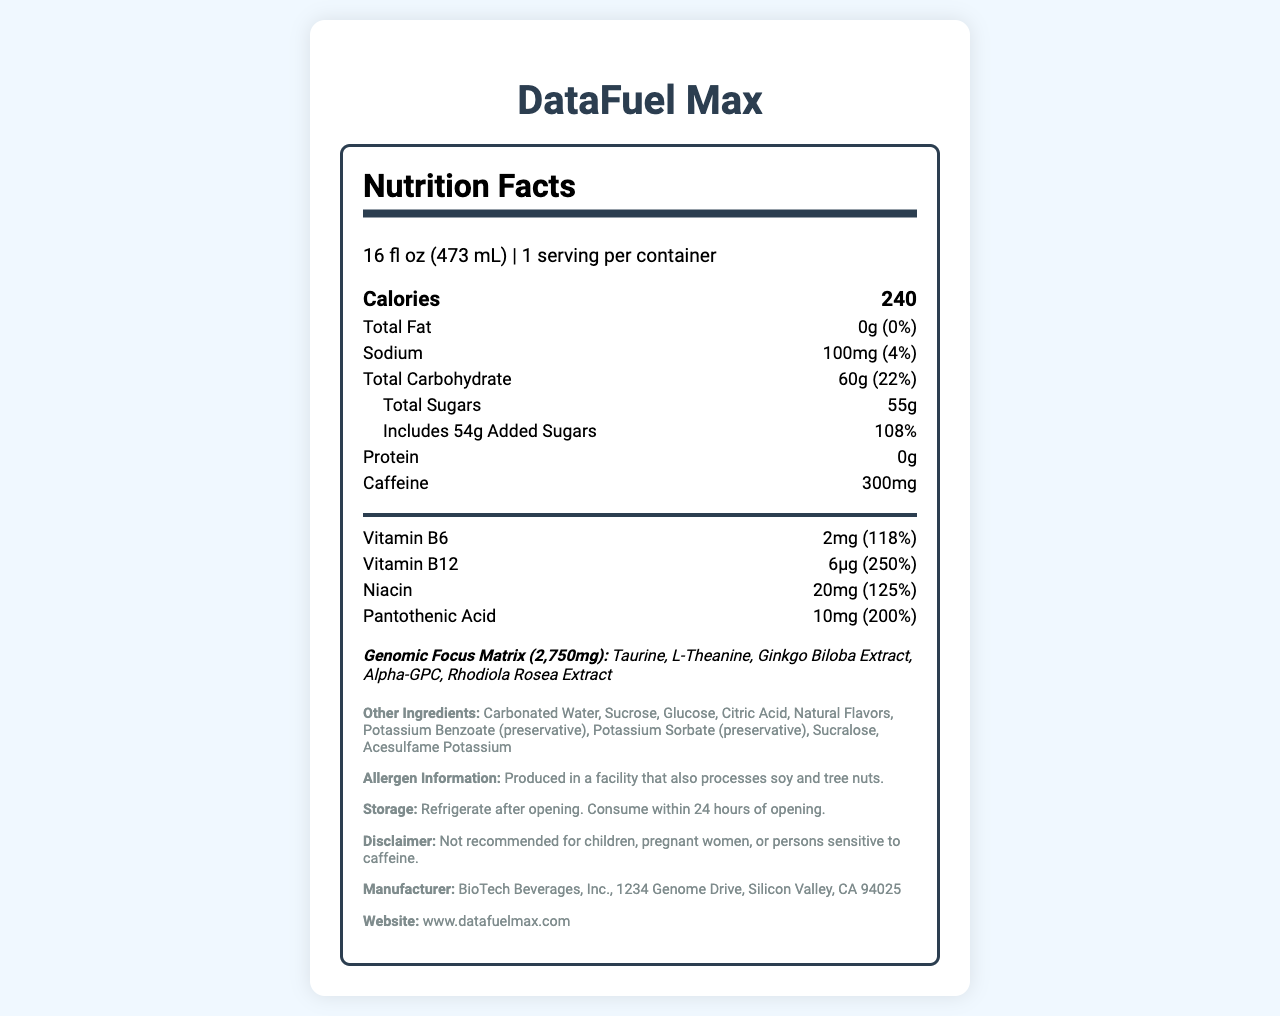What is the serving size of DataFuel Max? The serving size is clearly mentioned at the top of the nutrition facts section as "16 fl oz (473 mL)".
Answer: 16 fl oz (473 mL) What is the total amount of caffeine in one serving of this beverage? The nutrition facts section lists the amount of caffeine as 300mg.
Answer: 300mg What percentage of the daily value for Vitamin B12 does DataFuel Max provide? In the vitamins and minerals section, it is stated that Vitamin B12 provides 250% of the daily value.
Answer: 250% How many grams of added sugars are in one serving? The document lists the amount of added sugars under the total sugars section as 54g.
Answer: 54g Name one ingredient in the proprietary blend "Genomic Focus Matrix." The proprietary blend section lists the ingredients, one of which is Taurine.
Answer: Taurine Which of the following is true about the allergen information? A. Contains soy B. Contains tree nuts C. Produced in a facility that processes soy D. Produced in a facility that processes milk The allergen information states that the product is "Produced in a facility that processes soy and tree nuts."
Answer: C How much sodium is in each serving? A. 50mg B. 100mg C. 150mg D. 200mg The sodium content is listed as 100mg.
Answer: B Is this beverage recommended for children? The disclaimer clearly states "Not recommended for children, pregnant women, or persons sensitive to caffeine."
Answer: No Summarize the main idea of this Nutrition Facts Label. This beverage, called DataFuel Max, is designed for high-energy needs and contains substantial caffeine and vitamins. The label highlights its nutritional content, proprietary blend ingredients, allergen processes, and storage guidelines.
Answer: DataFuel Max is a high-energy beverage with significant amounts of caffeine, vitamins, and a proprietary blend targeted for professionals, packed with sugars and free of fats and proteins, and includes specific storage and allergen handling instructions. What is the primary source of carbohydrates in DataFuel Max? The document does not provide specific details about the sources of carbohydrates.
Answer: Not enough information What percentage of the daily value for Niacin does each serving provide? The vitamins and minerals section states that Niacin provides 125% of the daily value.
Answer: 125% 